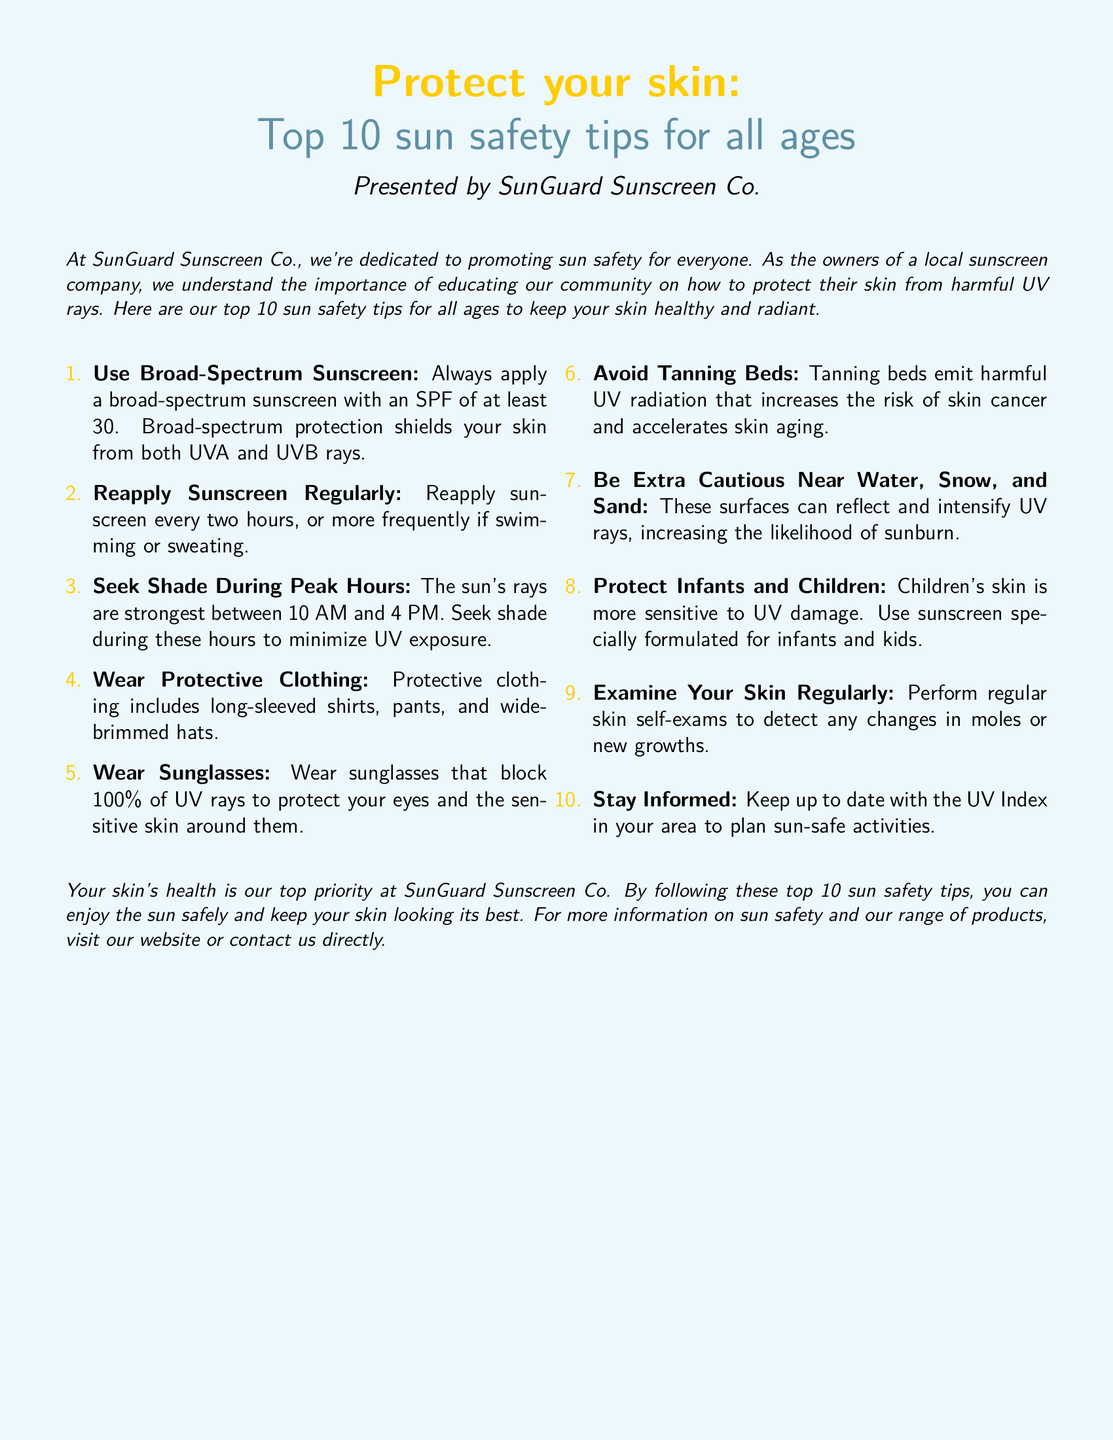What is the name of the sunscreen company? The document states that the sunscreen company is called SunGuard Sunscreen Co.
Answer: SunGuard Sunscreen Co What is the minimum SPF recommended? The document specifies that a broad-spectrum sunscreen should have an SPF of at least 30.
Answer: 30 How often should sunscreen be reapplied? According to the document, sunscreen should be reapplied every two hours or more frequently if swimming or sweating.
Answer: Every two hours What should you seek during peak sun hours? The text advises to seek shade during the sun's strongest hours, which are between 10 AM and 4 PM.
Answer: Shade Which clothing items provide protection from the sun? The document mentions long-sleeved shirts, pants, and wide-brimmed hats as protective clothing.
Answer: Long-sleeved shirts, pants, and wide-brimmed hats What should be examined regularly for skin health? The document recommends performing regular skin self-exams to detect changes in moles or new growths.
Answer: Skin What should children use for sun protection? The document states that children should use sunscreen specially formulated for infants and kids.
Answer: Sunscreen specially formulated for infants and kids What reflects and intensifies UV rays? The document lists water, snow, and sand as surfaces that can reflect and intensify UV rays.
Answer: Water, snow, and sand What is the overall priority of SunGuard Sunscreen Co.? The document emphasizes that the top priority at SunGuard is the health of your skin.
Answer: Skin's health 